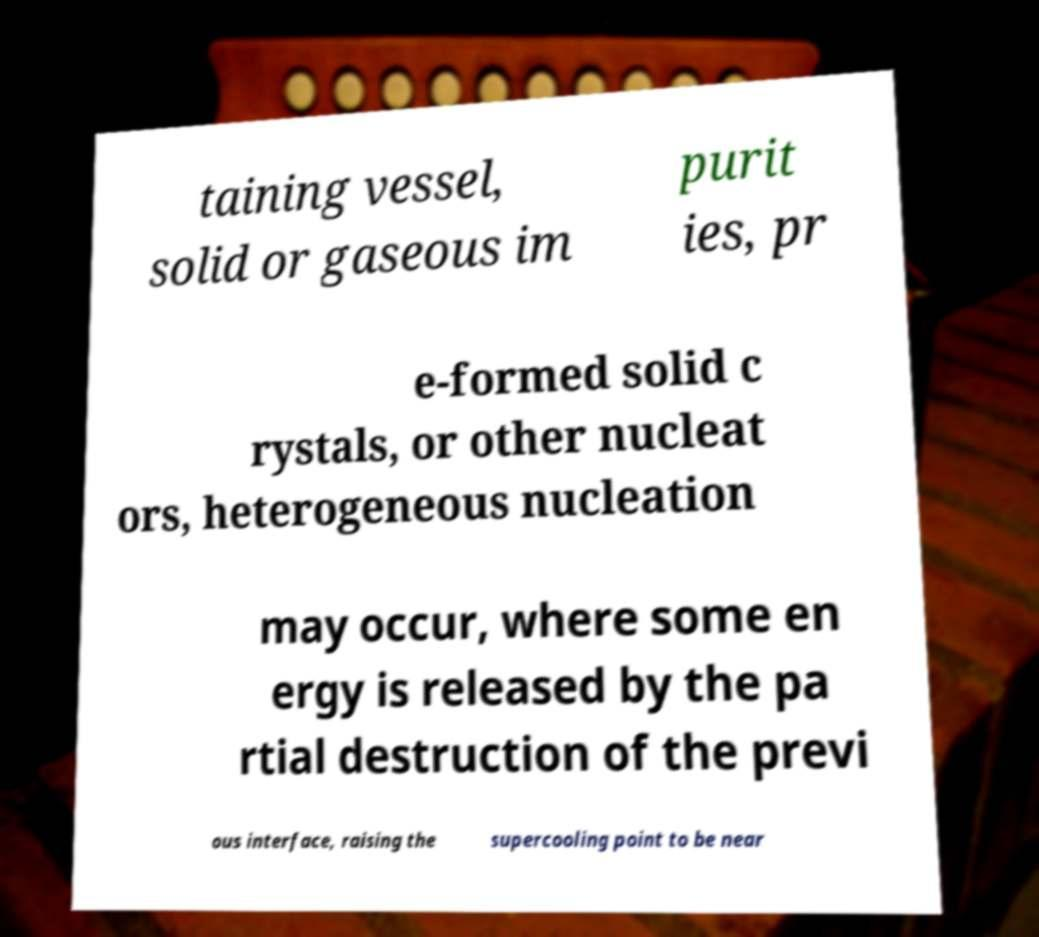What messages or text are displayed in this image? I need them in a readable, typed format. taining vessel, solid or gaseous im purit ies, pr e-formed solid c rystals, or other nucleat ors, heterogeneous nucleation may occur, where some en ergy is released by the pa rtial destruction of the previ ous interface, raising the supercooling point to be near 